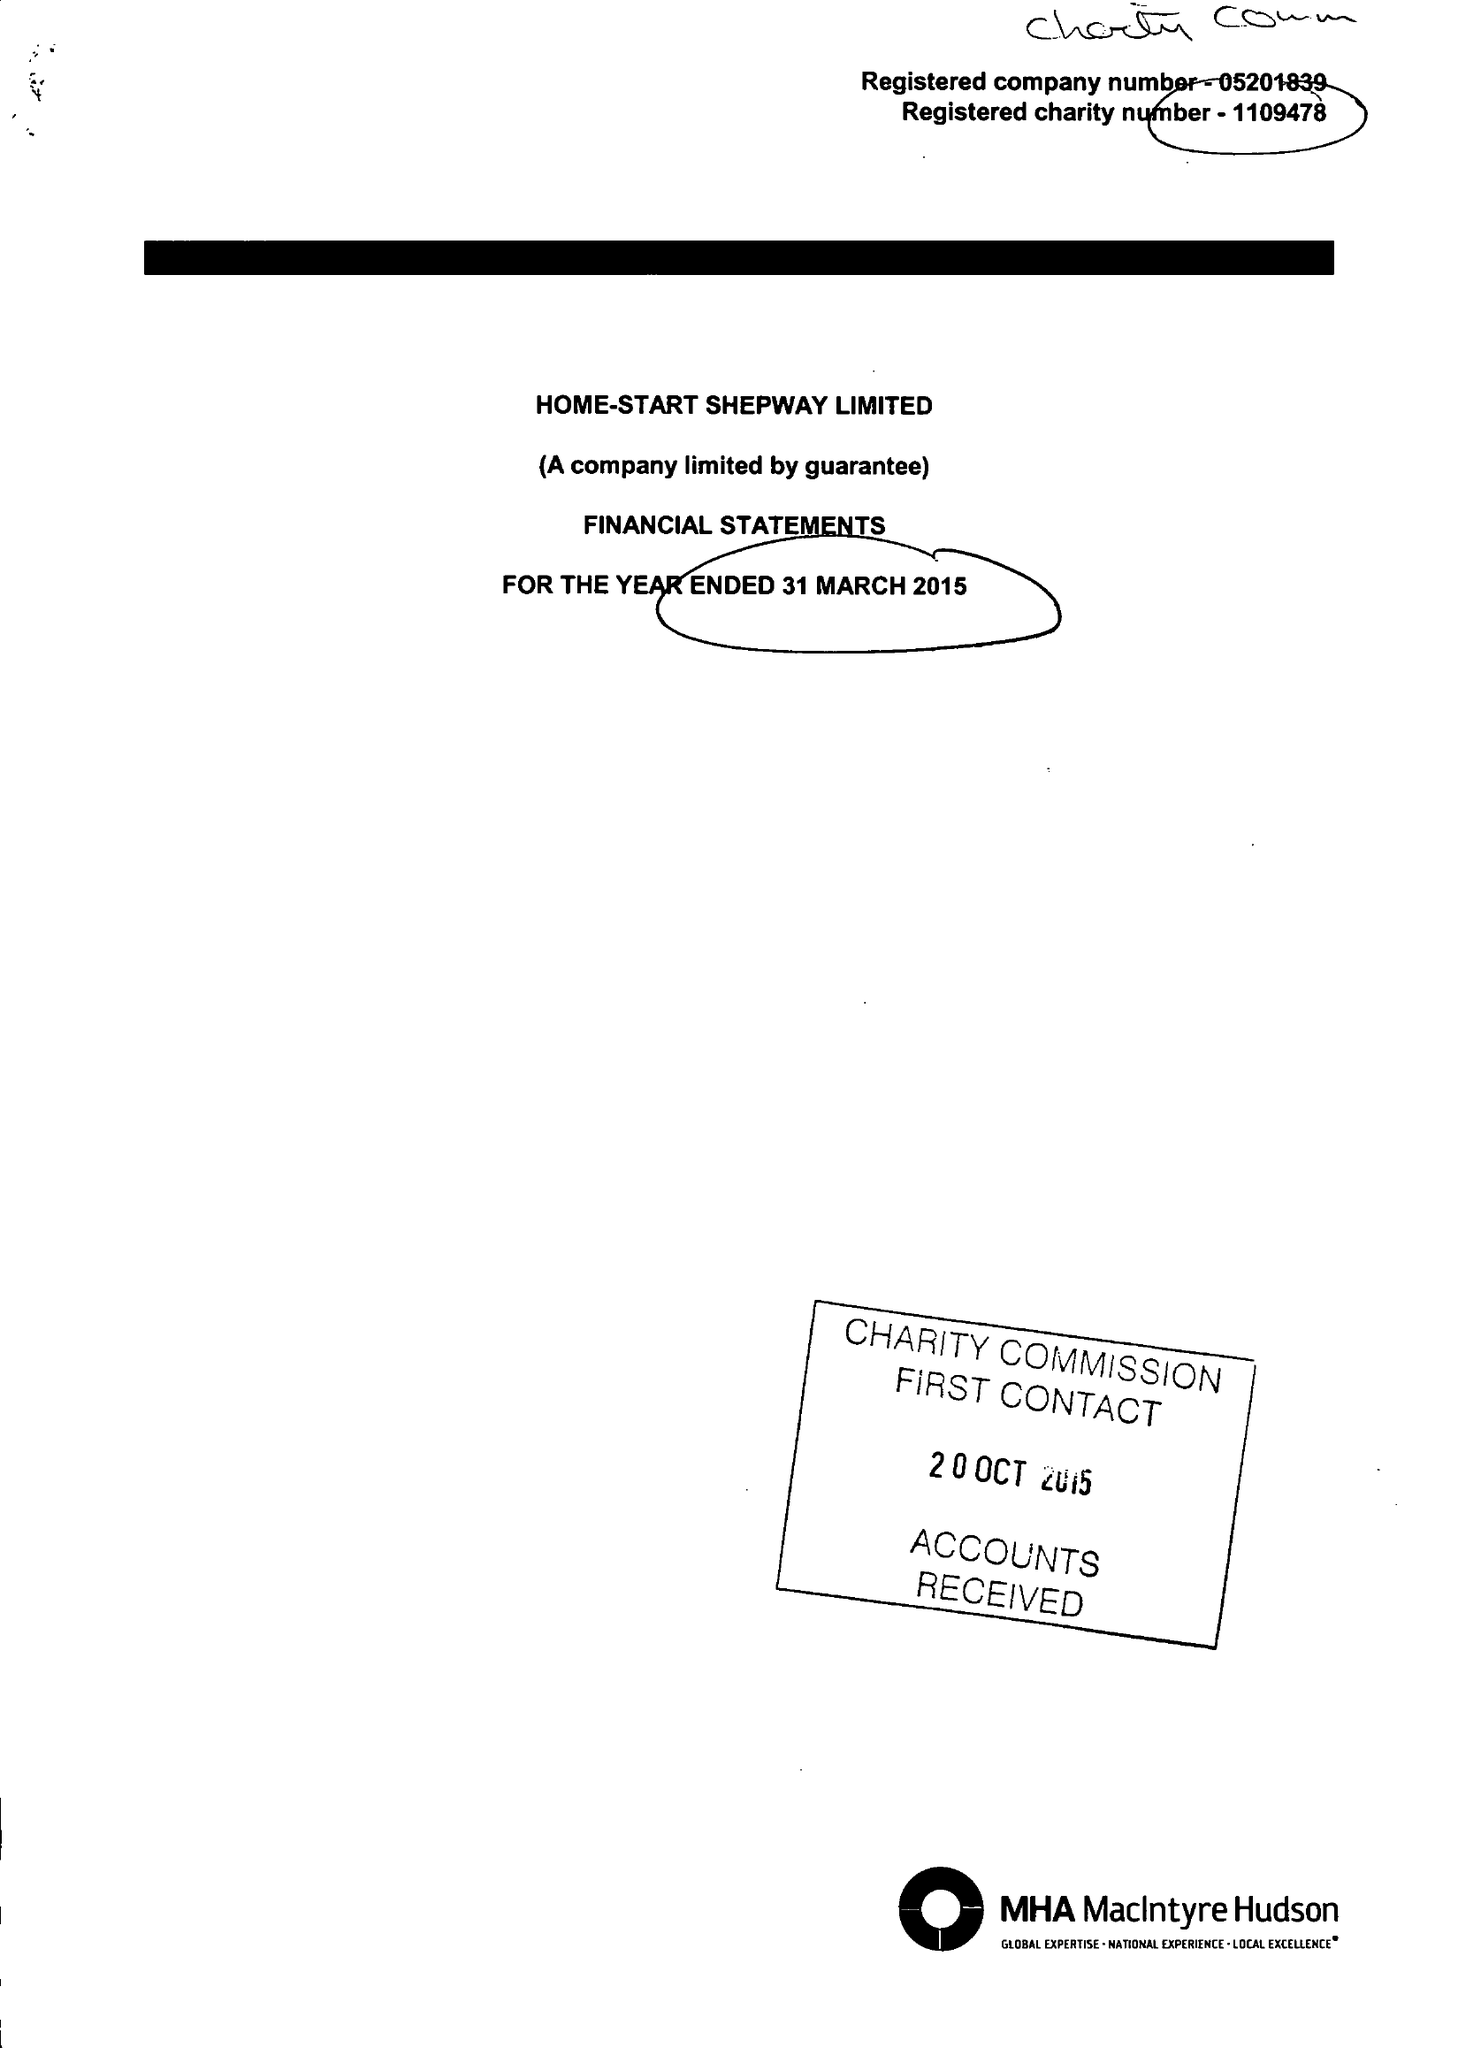What is the value for the address__post_town?
Answer the question using a single word or phrase. FOLKESTONE 